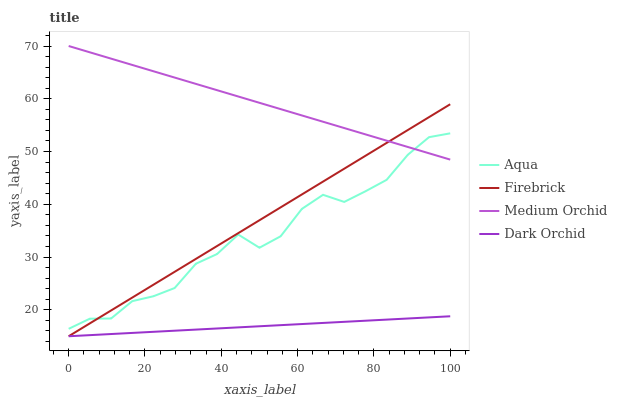Does Dark Orchid have the minimum area under the curve?
Answer yes or no. Yes. Does Medium Orchid have the maximum area under the curve?
Answer yes or no. Yes. Does Aqua have the minimum area under the curve?
Answer yes or no. No. Does Aqua have the maximum area under the curve?
Answer yes or no. No. Is Dark Orchid the smoothest?
Answer yes or no. Yes. Is Aqua the roughest?
Answer yes or no. Yes. Is Medium Orchid the smoothest?
Answer yes or no. No. Is Medium Orchid the roughest?
Answer yes or no. No. Does Firebrick have the lowest value?
Answer yes or no. Yes. Does Aqua have the lowest value?
Answer yes or no. No. Does Medium Orchid have the highest value?
Answer yes or no. Yes. Does Aqua have the highest value?
Answer yes or no. No. Is Dark Orchid less than Aqua?
Answer yes or no. Yes. Is Aqua greater than Dark Orchid?
Answer yes or no. Yes. Does Firebrick intersect Medium Orchid?
Answer yes or no. Yes. Is Firebrick less than Medium Orchid?
Answer yes or no. No. Is Firebrick greater than Medium Orchid?
Answer yes or no. No. Does Dark Orchid intersect Aqua?
Answer yes or no. No. 